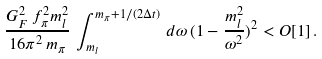<formula> <loc_0><loc_0><loc_500><loc_500>\frac { G _ { F } ^ { 2 } \, f _ { \pi } ^ { 2 } m _ { l } ^ { 2 } } { 1 6 \pi ^ { 2 } \, m _ { \pi } } \, \int _ { m _ { l } } ^ { m _ { \pi } + 1 / ( 2 \Delta t ) } \, d \omega \, ( 1 - \frac { m _ { l } ^ { 2 } } { \omega ^ { 2 } } ) ^ { 2 } < O [ 1 ] \, .</formula> 